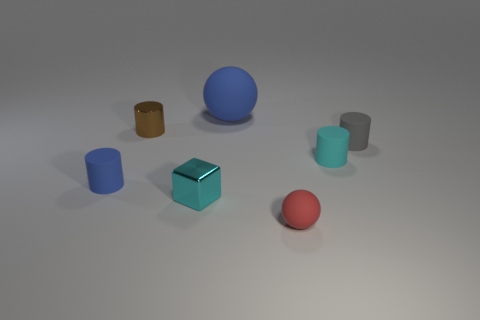Subtract all yellow cylinders. Subtract all red balls. How many cylinders are left? 4 Add 2 large matte things. How many objects exist? 9 Subtract all cylinders. How many objects are left? 3 Add 5 tiny brown cylinders. How many tiny brown cylinders exist? 6 Subtract 0 yellow spheres. How many objects are left? 7 Subtract all small balls. Subtract all big blue matte things. How many objects are left? 5 Add 6 large balls. How many large balls are left? 7 